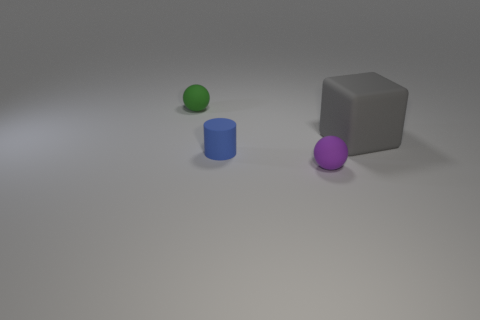Add 1 blocks. How many objects exist? 5 Subtract 1 spheres. How many spheres are left? 1 Subtract all blocks. How many objects are left? 3 Subtract all small metallic objects. Subtract all tiny spheres. How many objects are left? 2 Add 1 green things. How many green things are left? 2 Add 4 small green rubber things. How many small green rubber things exist? 5 Subtract 0 gray spheres. How many objects are left? 4 Subtract all gray balls. Subtract all red blocks. How many balls are left? 2 Subtract all green balls. How many gray cylinders are left? 0 